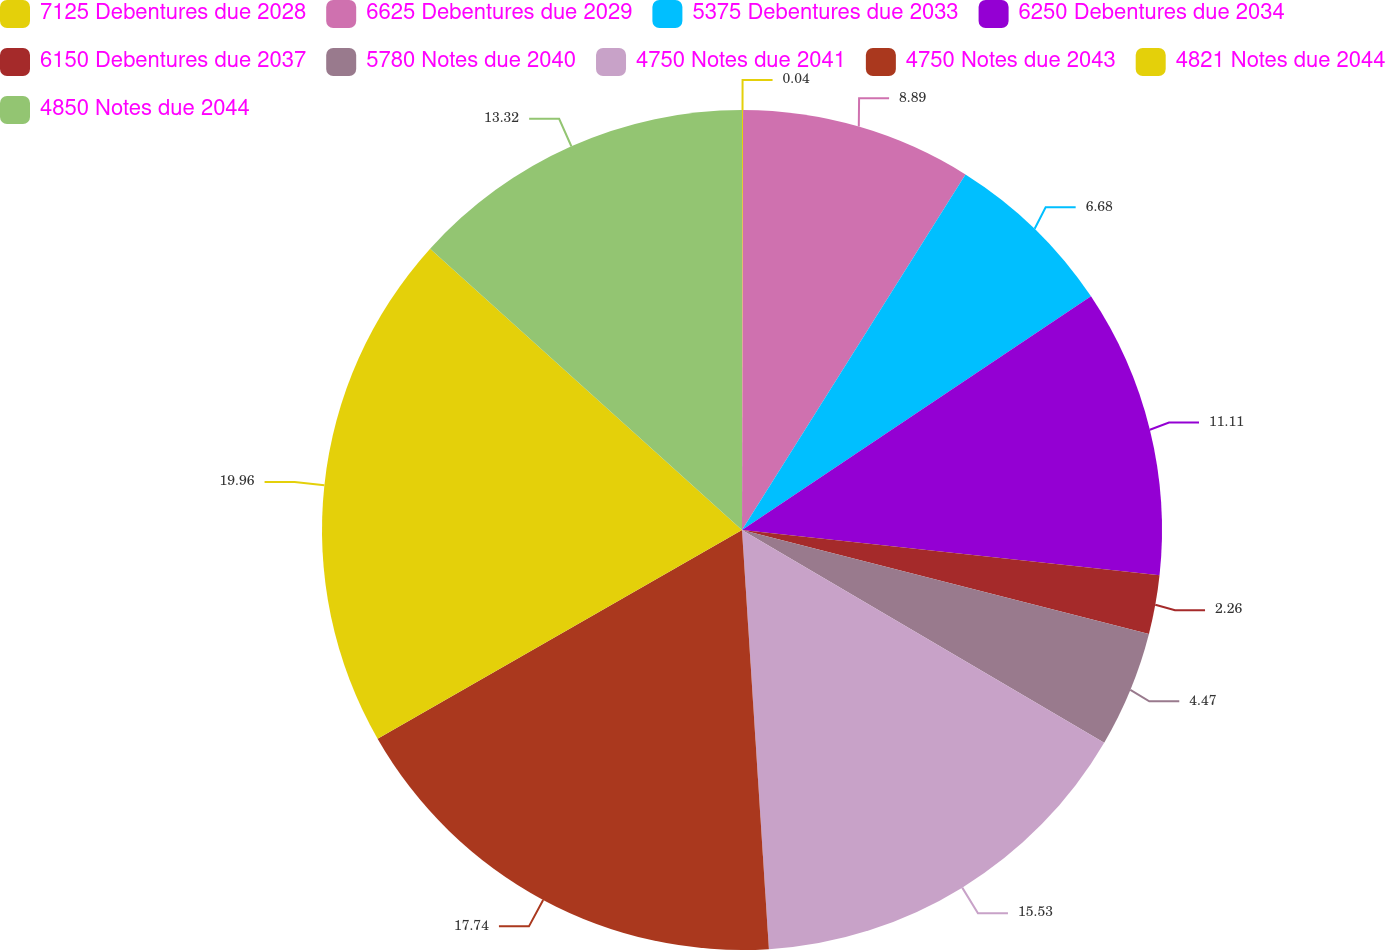Convert chart to OTSL. <chart><loc_0><loc_0><loc_500><loc_500><pie_chart><fcel>7125 Debentures due 2028<fcel>6625 Debentures due 2029<fcel>5375 Debentures due 2033<fcel>6250 Debentures due 2034<fcel>6150 Debentures due 2037<fcel>5780 Notes due 2040<fcel>4750 Notes due 2041<fcel>4750 Notes due 2043<fcel>4821 Notes due 2044<fcel>4850 Notes due 2044<nl><fcel>0.04%<fcel>8.89%<fcel>6.68%<fcel>11.11%<fcel>2.26%<fcel>4.47%<fcel>15.53%<fcel>17.74%<fcel>19.96%<fcel>13.32%<nl></chart> 